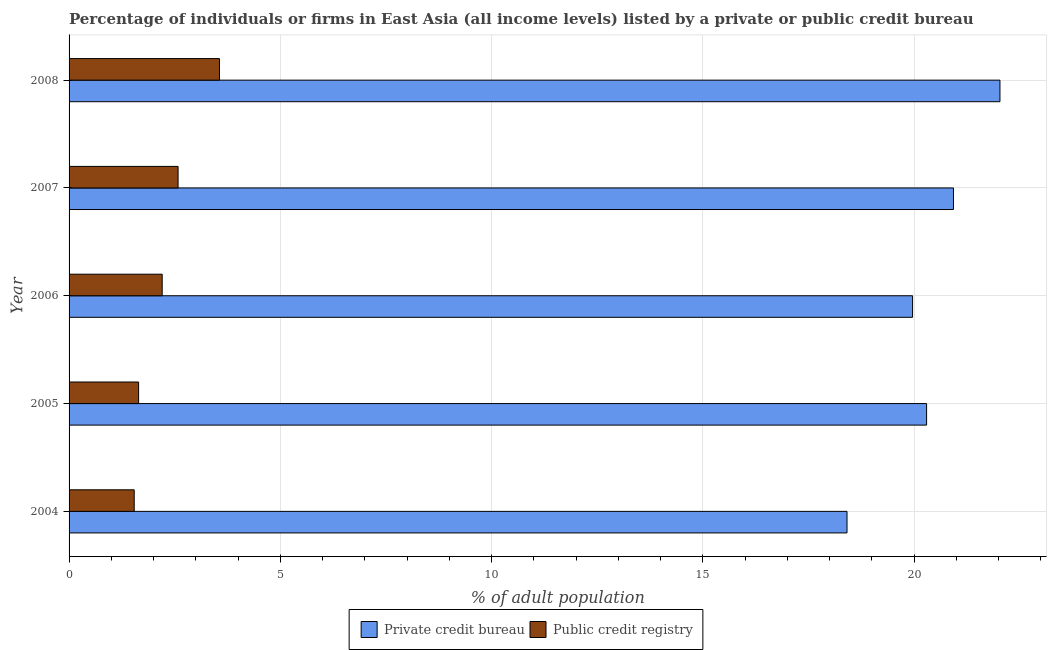How many different coloured bars are there?
Your answer should be very brief. 2. How many groups of bars are there?
Offer a terse response. 5. How many bars are there on the 4th tick from the top?
Provide a succinct answer. 2. What is the label of the 1st group of bars from the top?
Make the answer very short. 2008. What is the percentage of firms listed by private credit bureau in 2006?
Make the answer very short. 19.96. Across all years, what is the maximum percentage of firms listed by private credit bureau?
Give a very brief answer. 22.03. Across all years, what is the minimum percentage of firms listed by public credit bureau?
Provide a short and direct response. 1.54. In which year was the percentage of firms listed by private credit bureau minimum?
Your answer should be compact. 2004. What is the total percentage of firms listed by private credit bureau in the graph?
Keep it short and to the point. 101.64. What is the difference between the percentage of firms listed by public credit bureau in 2007 and that in 2008?
Make the answer very short. -0.98. What is the difference between the percentage of firms listed by private credit bureau in 2008 and the percentage of firms listed by public credit bureau in 2006?
Keep it short and to the point. 19.83. What is the average percentage of firms listed by public credit bureau per year?
Ensure brevity in your answer.  2.31. In the year 2006, what is the difference between the percentage of firms listed by private credit bureau and percentage of firms listed by public credit bureau?
Your answer should be very brief. 17.76. What is the ratio of the percentage of firms listed by public credit bureau in 2005 to that in 2007?
Ensure brevity in your answer.  0.64. Is the difference between the percentage of firms listed by public credit bureau in 2005 and 2008 greater than the difference between the percentage of firms listed by private credit bureau in 2005 and 2008?
Keep it short and to the point. No. What is the difference between the highest and the second highest percentage of firms listed by private credit bureau?
Your answer should be very brief. 1.1. What is the difference between the highest and the lowest percentage of firms listed by private credit bureau?
Your response must be concise. 3.62. What does the 2nd bar from the top in 2004 represents?
Provide a succinct answer. Private credit bureau. What does the 2nd bar from the bottom in 2004 represents?
Give a very brief answer. Public credit registry. How many bars are there?
Your answer should be compact. 10. Are all the bars in the graph horizontal?
Offer a very short reply. Yes. How many years are there in the graph?
Make the answer very short. 5. What is the difference between two consecutive major ticks on the X-axis?
Your response must be concise. 5. Are the values on the major ticks of X-axis written in scientific E-notation?
Provide a short and direct response. No. How are the legend labels stacked?
Keep it short and to the point. Horizontal. What is the title of the graph?
Keep it short and to the point. Percentage of individuals or firms in East Asia (all income levels) listed by a private or public credit bureau. What is the label or title of the X-axis?
Keep it short and to the point. % of adult population. What is the label or title of the Y-axis?
Your response must be concise. Year. What is the % of adult population of Private credit bureau in 2004?
Your answer should be compact. 18.41. What is the % of adult population of Public credit registry in 2004?
Make the answer very short. 1.54. What is the % of adult population of Private credit bureau in 2005?
Give a very brief answer. 20.3. What is the % of adult population in Public credit registry in 2005?
Provide a short and direct response. 1.65. What is the % of adult population in Private credit bureau in 2006?
Your answer should be very brief. 19.96. What is the % of adult population of Public credit registry in 2006?
Provide a short and direct response. 2.2. What is the % of adult population in Private credit bureau in 2007?
Offer a very short reply. 20.93. What is the % of adult population of Public credit registry in 2007?
Keep it short and to the point. 2.58. What is the % of adult population in Private credit bureau in 2008?
Your answer should be very brief. 22.03. What is the % of adult population of Public credit registry in 2008?
Offer a terse response. 3.56. Across all years, what is the maximum % of adult population of Private credit bureau?
Give a very brief answer. 22.03. Across all years, what is the maximum % of adult population in Public credit registry?
Provide a succinct answer. 3.56. Across all years, what is the minimum % of adult population of Private credit bureau?
Your response must be concise. 18.41. Across all years, what is the minimum % of adult population in Public credit registry?
Make the answer very short. 1.54. What is the total % of adult population in Private credit bureau in the graph?
Ensure brevity in your answer.  101.64. What is the total % of adult population of Public credit registry in the graph?
Give a very brief answer. 11.53. What is the difference between the % of adult population of Private credit bureau in 2004 and that in 2005?
Your answer should be very brief. -1.88. What is the difference between the % of adult population in Public credit registry in 2004 and that in 2005?
Your answer should be compact. -0.1. What is the difference between the % of adult population of Private credit bureau in 2004 and that in 2006?
Make the answer very short. -1.55. What is the difference between the % of adult population of Public credit registry in 2004 and that in 2006?
Offer a very short reply. -0.66. What is the difference between the % of adult population of Private credit bureau in 2004 and that in 2007?
Your answer should be compact. -2.52. What is the difference between the % of adult population in Public credit registry in 2004 and that in 2007?
Offer a terse response. -1.04. What is the difference between the % of adult population in Private credit bureau in 2004 and that in 2008?
Your answer should be compact. -3.62. What is the difference between the % of adult population in Public credit registry in 2004 and that in 2008?
Your answer should be very brief. -2.02. What is the difference between the % of adult population of Private credit bureau in 2005 and that in 2006?
Offer a terse response. 0.33. What is the difference between the % of adult population of Public credit registry in 2005 and that in 2006?
Keep it short and to the point. -0.56. What is the difference between the % of adult population in Private credit bureau in 2005 and that in 2007?
Your answer should be very brief. -0.64. What is the difference between the % of adult population in Public credit registry in 2005 and that in 2007?
Your response must be concise. -0.93. What is the difference between the % of adult population in Private credit bureau in 2005 and that in 2008?
Provide a short and direct response. -1.74. What is the difference between the % of adult population in Public credit registry in 2005 and that in 2008?
Offer a terse response. -1.91. What is the difference between the % of adult population in Private credit bureau in 2006 and that in 2007?
Your response must be concise. -0.97. What is the difference between the % of adult population in Public credit registry in 2006 and that in 2007?
Offer a very short reply. -0.38. What is the difference between the % of adult population in Private credit bureau in 2006 and that in 2008?
Give a very brief answer. -2.07. What is the difference between the % of adult population of Public credit registry in 2006 and that in 2008?
Offer a very short reply. -1.36. What is the difference between the % of adult population in Public credit registry in 2007 and that in 2008?
Provide a short and direct response. -0.98. What is the difference between the % of adult population of Private credit bureau in 2004 and the % of adult population of Public credit registry in 2005?
Ensure brevity in your answer.  16.77. What is the difference between the % of adult population of Private credit bureau in 2004 and the % of adult population of Public credit registry in 2006?
Make the answer very short. 16.21. What is the difference between the % of adult population of Private credit bureau in 2004 and the % of adult population of Public credit registry in 2007?
Provide a short and direct response. 15.83. What is the difference between the % of adult population in Private credit bureau in 2004 and the % of adult population in Public credit registry in 2008?
Offer a terse response. 14.85. What is the difference between the % of adult population of Private credit bureau in 2005 and the % of adult population of Public credit registry in 2006?
Make the answer very short. 18.09. What is the difference between the % of adult population in Private credit bureau in 2005 and the % of adult population in Public credit registry in 2007?
Your answer should be compact. 17.72. What is the difference between the % of adult population of Private credit bureau in 2005 and the % of adult population of Public credit registry in 2008?
Your answer should be very brief. 16.74. What is the difference between the % of adult population in Private credit bureau in 2006 and the % of adult population in Public credit registry in 2007?
Ensure brevity in your answer.  17.38. What is the difference between the % of adult population in Private credit bureau in 2006 and the % of adult population in Public credit registry in 2008?
Keep it short and to the point. 16.4. What is the difference between the % of adult population of Private credit bureau in 2007 and the % of adult population of Public credit registry in 2008?
Make the answer very short. 17.37. What is the average % of adult population in Private credit bureau per year?
Make the answer very short. 20.33. What is the average % of adult population of Public credit registry per year?
Ensure brevity in your answer.  2.31. In the year 2004, what is the difference between the % of adult population in Private credit bureau and % of adult population in Public credit registry?
Provide a succinct answer. 16.87. In the year 2005, what is the difference between the % of adult population of Private credit bureau and % of adult population of Public credit registry?
Provide a short and direct response. 18.65. In the year 2006, what is the difference between the % of adult population of Private credit bureau and % of adult population of Public credit registry?
Make the answer very short. 17.76. In the year 2007, what is the difference between the % of adult population of Private credit bureau and % of adult population of Public credit registry?
Make the answer very short. 18.35. In the year 2008, what is the difference between the % of adult population of Private credit bureau and % of adult population of Public credit registry?
Ensure brevity in your answer.  18.47. What is the ratio of the % of adult population of Private credit bureau in 2004 to that in 2005?
Ensure brevity in your answer.  0.91. What is the ratio of the % of adult population in Public credit registry in 2004 to that in 2005?
Offer a terse response. 0.94. What is the ratio of the % of adult population of Private credit bureau in 2004 to that in 2006?
Your answer should be very brief. 0.92. What is the ratio of the % of adult population in Public credit registry in 2004 to that in 2006?
Offer a terse response. 0.7. What is the ratio of the % of adult population in Private credit bureau in 2004 to that in 2007?
Make the answer very short. 0.88. What is the ratio of the % of adult population of Public credit registry in 2004 to that in 2007?
Your answer should be compact. 0.6. What is the ratio of the % of adult population of Private credit bureau in 2004 to that in 2008?
Make the answer very short. 0.84. What is the ratio of the % of adult population in Public credit registry in 2004 to that in 2008?
Offer a terse response. 0.43. What is the ratio of the % of adult population in Private credit bureau in 2005 to that in 2006?
Make the answer very short. 1.02. What is the ratio of the % of adult population of Public credit registry in 2005 to that in 2006?
Your response must be concise. 0.75. What is the ratio of the % of adult population in Private credit bureau in 2005 to that in 2007?
Keep it short and to the point. 0.97. What is the ratio of the % of adult population of Public credit registry in 2005 to that in 2007?
Your answer should be compact. 0.64. What is the ratio of the % of adult population in Private credit bureau in 2005 to that in 2008?
Provide a succinct answer. 0.92. What is the ratio of the % of adult population of Public credit registry in 2005 to that in 2008?
Ensure brevity in your answer.  0.46. What is the ratio of the % of adult population in Private credit bureau in 2006 to that in 2007?
Offer a terse response. 0.95. What is the ratio of the % of adult population in Public credit registry in 2006 to that in 2007?
Ensure brevity in your answer.  0.85. What is the ratio of the % of adult population of Private credit bureau in 2006 to that in 2008?
Your response must be concise. 0.91. What is the ratio of the % of adult population of Public credit registry in 2006 to that in 2008?
Keep it short and to the point. 0.62. What is the ratio of the % of adult population in Private credit bureau in 2007 to that in 2008?
Give a very brief answer. 0.95. What is the ratio of the % of adult population in Public credit registry in 2007 to that in 2008?
Ensure brevity in your answer.  0.72. What is the difference between the highest and the second highest % of adult population in Public credit registry?
Provide a short and direct response. 0.98. What is the difference between the highest and the lowest % of adult population in Private credit bureau?
Keep it short and to the point. 3.62. What is the difference between the highest and the lowest % of adult population in Public credit registry?
Offer a terse response. 2.02. 